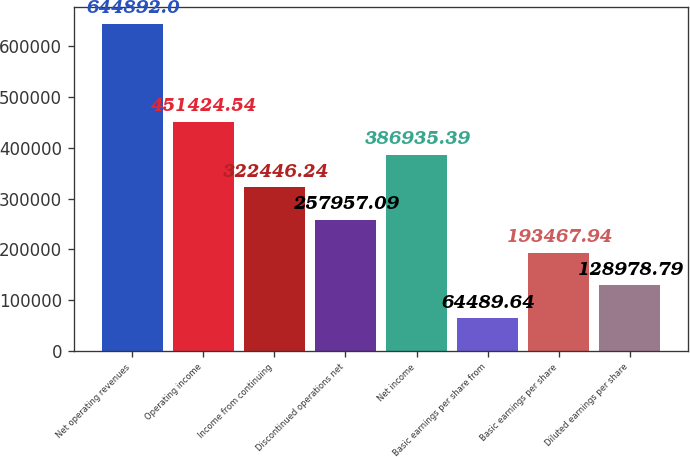<chart> <loc_0><loc_0><loc_500><loc_500><bar_chart><fcel>Net operating revenues<fcel>Operating income<fcel>Income from continuing<fcel>Discontinued operations net<fcel>Net income<fcel>Basic earnings per share from<fcel>Basic earnings per share<fcel>Diluted earnings per share<nl><fcel>644892<fcel>451425<fcel>322446<fcel>257957<fcel>386935<fcel>64489.6<fcel>193468<fcel>128979<nl></chart> 